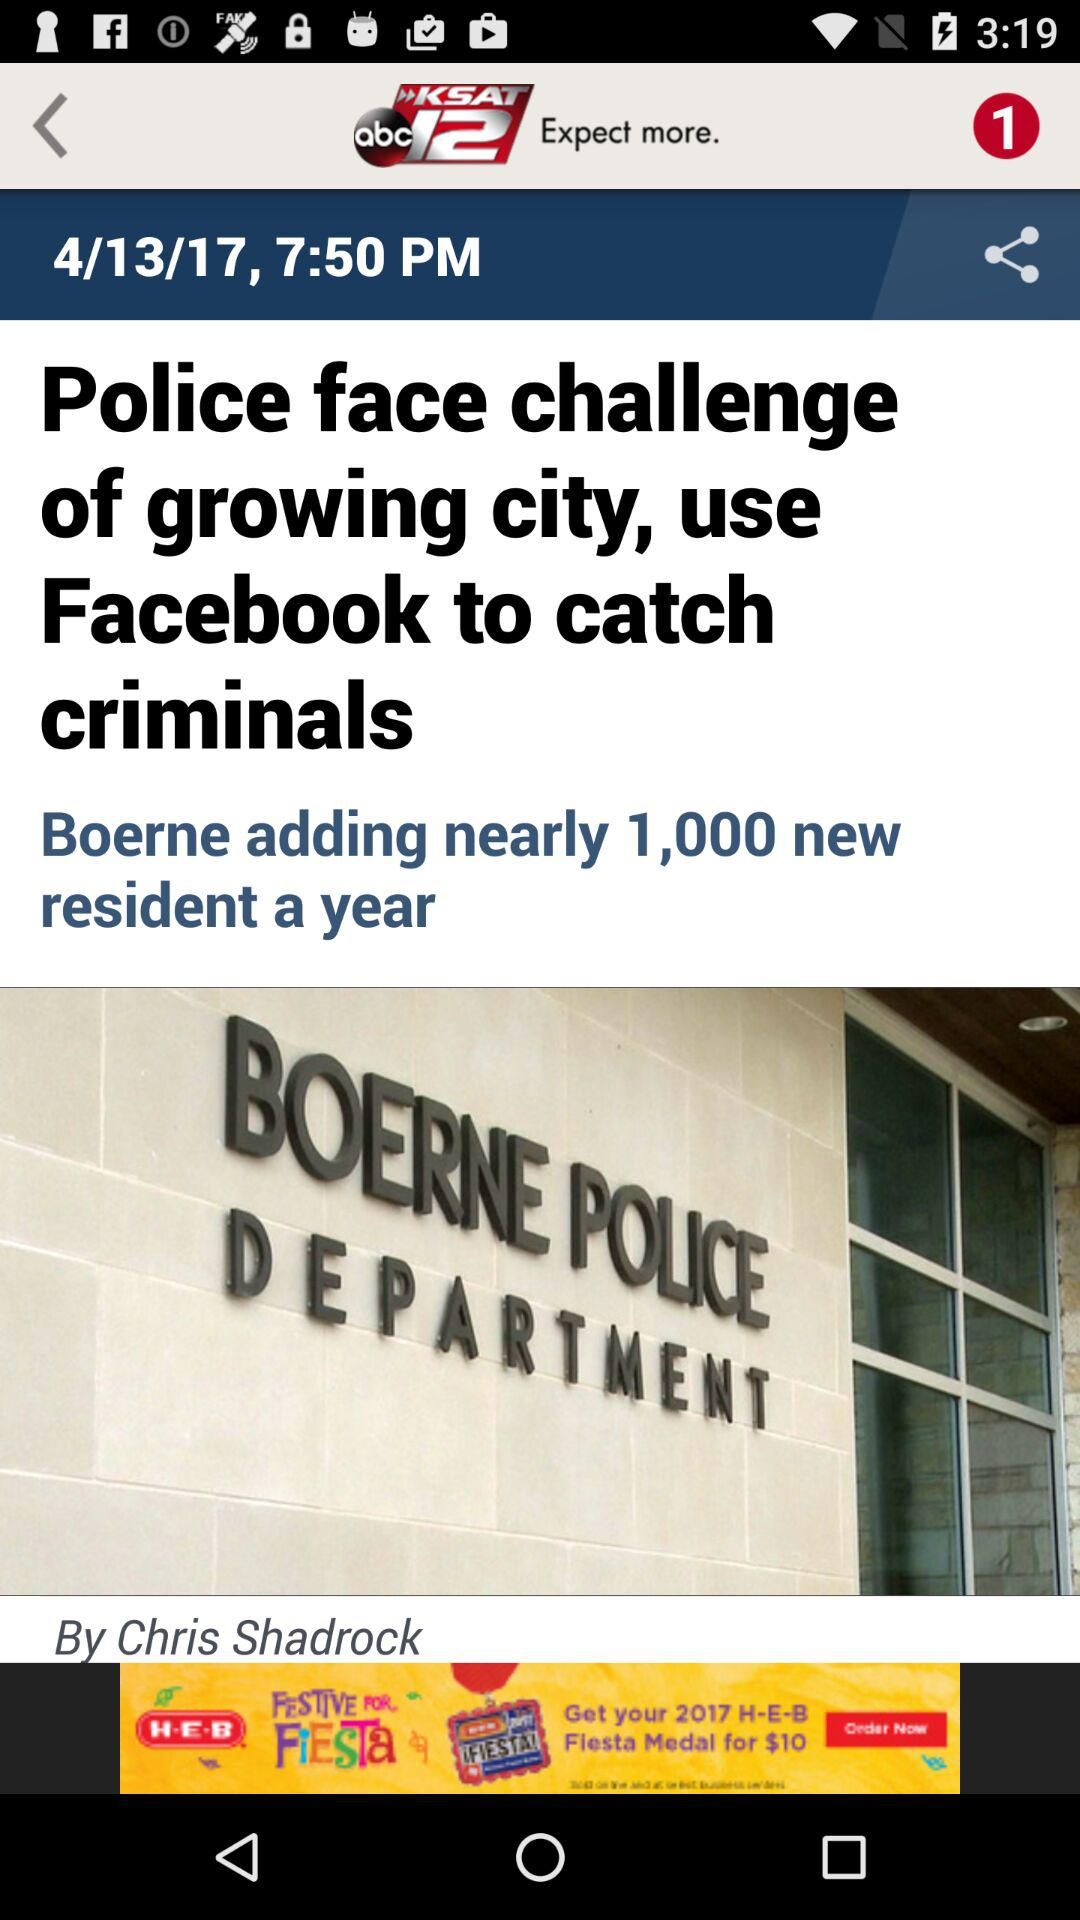Who is the author of the article? The author of the article is Chris Shadrock. 